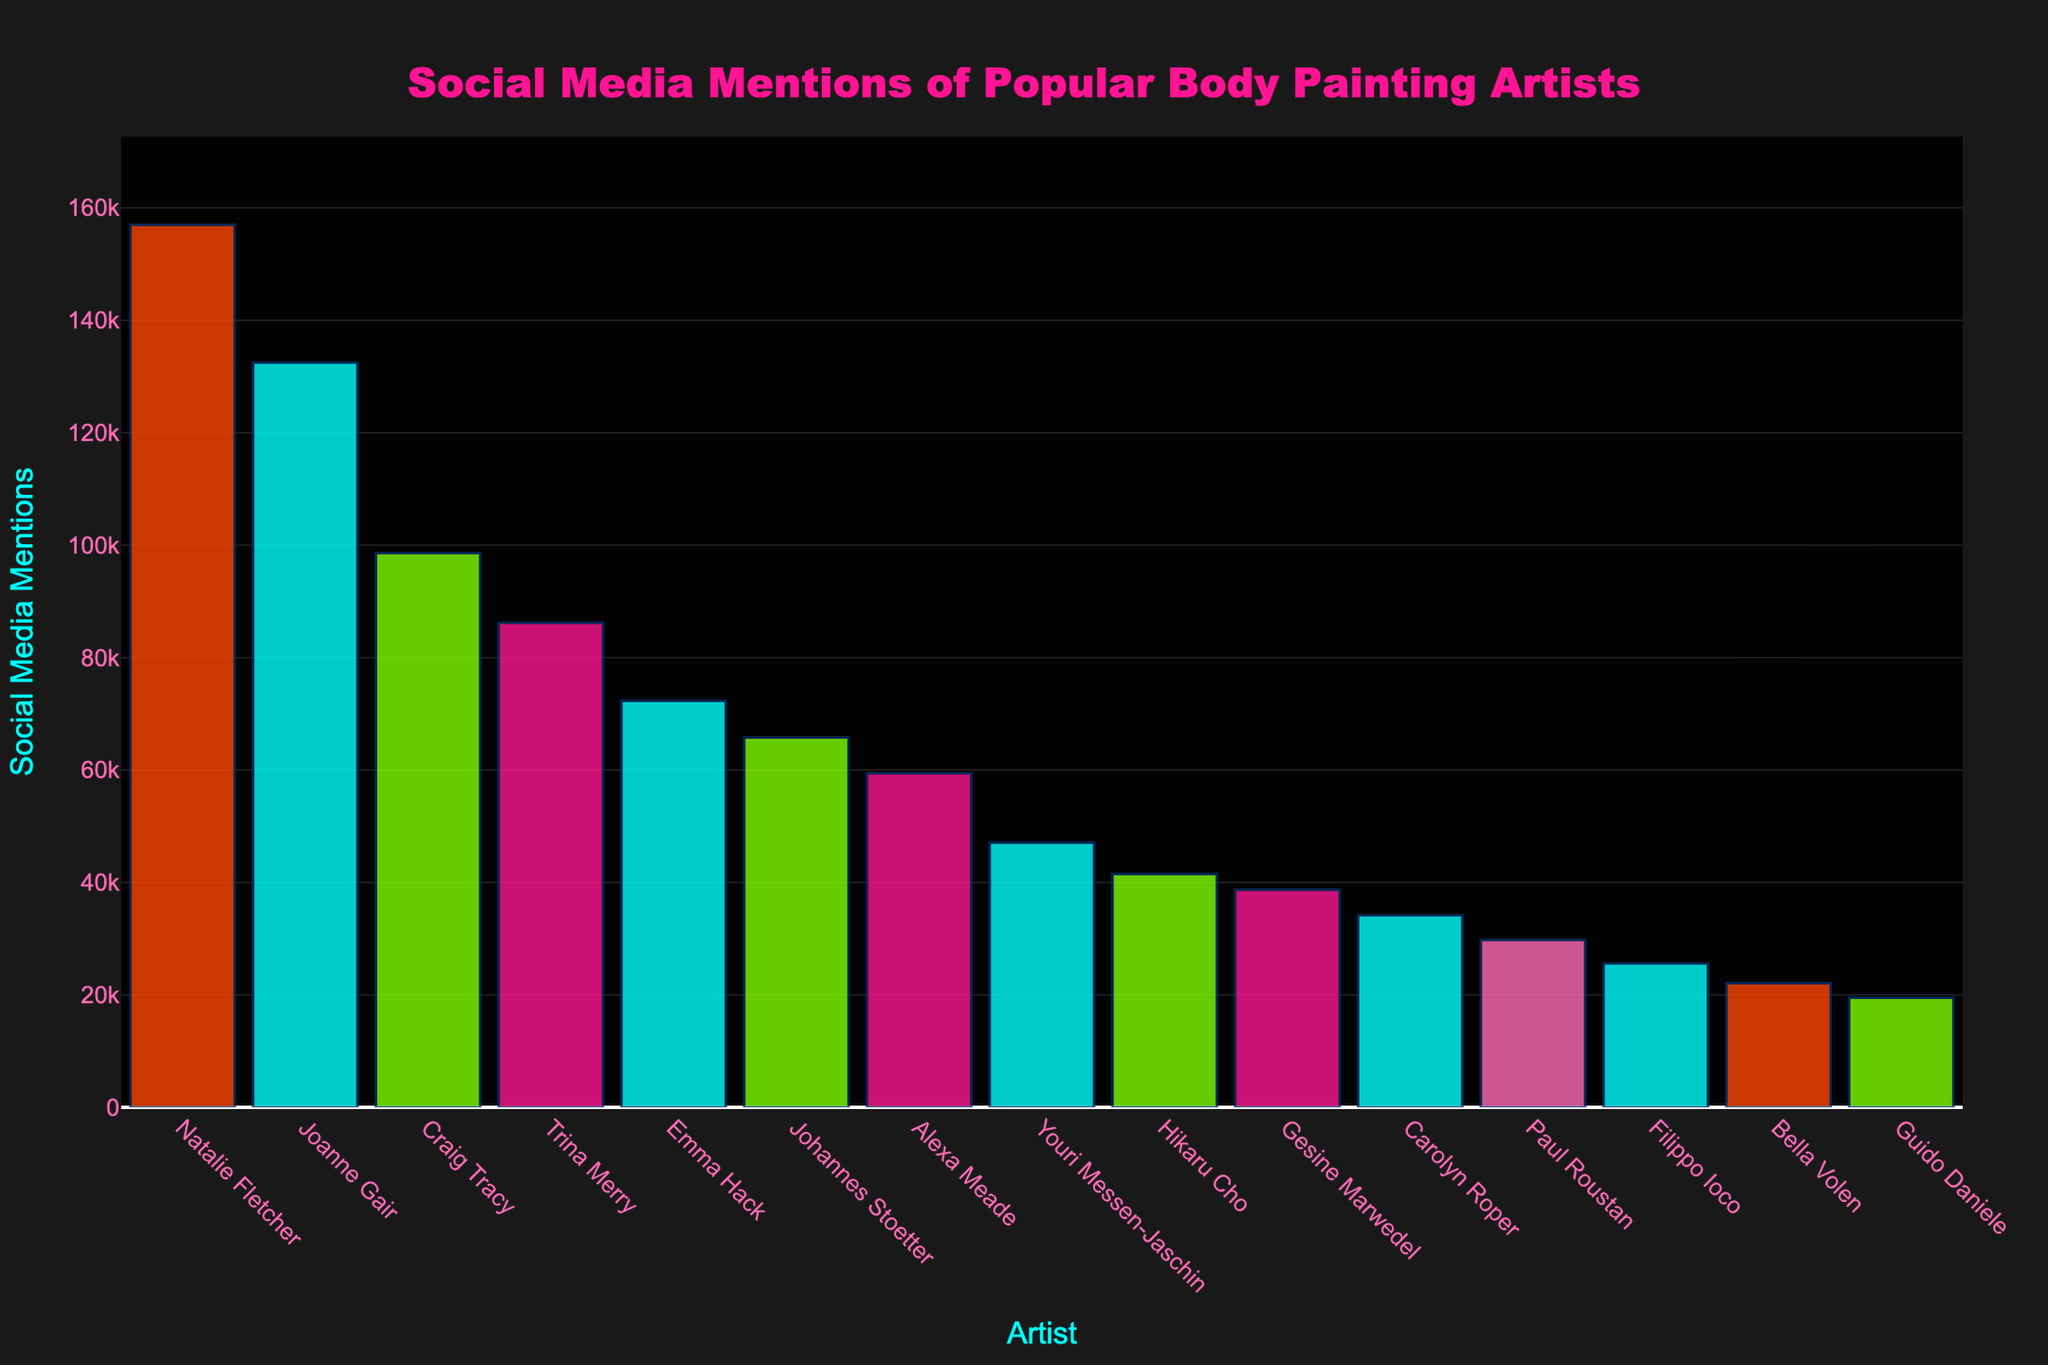Which artist has the highest number of social media mentions? Look at the height of the bars and identify the one with the greatest value. Natalie Fletcher's bar is the highest, indicating she has the highest number of social media mentions.
Answer: Natalie Fletcher How many more social media mentions does Natalie Fletcher have compared to Joanne Gair? Subtract the social media mentions of Joanne Gair from those of Natalie Fletcher. 157000 - 132500
Answer: 24500 Which artist has the fewest social media mentions and what is the number? Look at the shortest bar to find the artist with the fewest mentions. Guido Daniele's bar is the shortest.
Answer: Guido Daniele, 19500 What is the total number of social media mentions for the top 3 artists? Sum the social media mentions of the top 3 artists, Natalie Fletcher (157000), Joanne Gair (132500), and Craig Tracy (98600). 157000 + 132500 + 98600
Answer: 388100 Is the difference between the social media mentions of Craig Tracy and Trina Merry greater than 10000? Subtract Trina Merry's mentions from Craig Tracy's and compare the result with 10000. 98600 - 86200 = 12400, which is greater than 10000.
Answer: Yes What is the average number of social media mentions for the first five artists? Add the social media mentions of the first five artists and divide the sum by 5. (157000 + 132500 + 98600 + 86200 + 72300) / 5 = 109320
Answer: 109320 How do the social media mentions of Alexa Meade compare to those of Hikaru Cho? Compare the heights of the bars for Alexa Meade and Hikaru Cho. Alexa Meade's bar is taller than Hikaru Cho's. 59400 vs 41500.
Answer: Alexa Meade has more mentions What is the range of social media mentions among the artists? Subtract the smallest number of social media mentions (Guido Daniele, 19500) from the largest number (Natalie Fletcher, 157000). 157000 - 19500
Answer: 137500 Are there any artists with social media mentions between 40000 and 80000? Look at the bars that fall within this range on the y-axis. Johannes Stoetter (65800), Alexa Meade (59400), and Hikaru Cho (41500) fall within this range.
Answer: Yes, three artists 